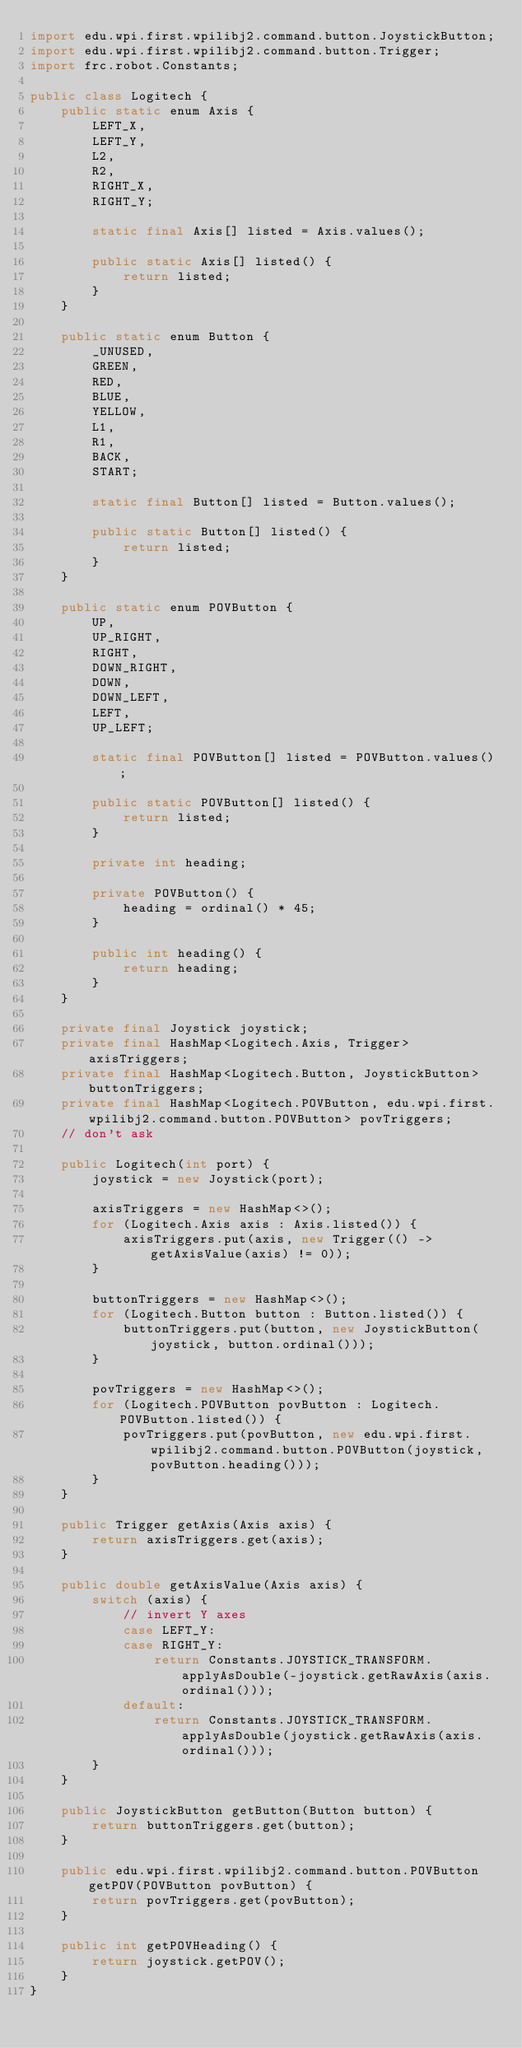Convert code to text. <code><loc_0><loc_0><loc_500><loc_500><_Java_>import edu.wpi.first.wpilibj2.command.button.JoystickButton;
import edu.wpi.first.wpilibj2.command.button.Trigger;
import frc.robot.Constants;

public class Logitech {
    public static enum Axis {
        LEFT_X,
        LEFT_Y,
        L2,
        R2,
        RIGHT_X,
        RIGHT_Y;

        static final Axis[] listed = Axis.values();

        public static Axis[] listed() {
            return listed;
        }
    }

    public static enum Button {
        _UNUSED,
        GREEN,
        RED,
        BLUE,
        YELLOW,
        L1,
        R1,
        BACK,
        START;
    
        static final Button[] listed = Button.values();

        public static Button[] listed() {
            return listed;
        }
    }

    public static enum POVButton {
        UP,
        UP_RIGHT,
        RIGHT,
        DOWN_RIGHT,
        DOWN,
        DOWN_LEFT,
        LEFT,
        UP_LEFT;

        static final POVButton[] listed = POVButton.values();

        public static POVButton[] listed() {
            return listed;
        }

        private int heading;

        private POVButton() {
            heading = ordinal() * 45;
        }

        public int heading() {
            return heading;
        }
    }

    private final Joystick joystick;
    private final HashMap<Logitech.Axis, Trigger> axisTriggers;
    private final HashMap<Logitech.Button, JoystickButton> buttonTriggers;
    private final HashMap<Logitech.POVButton, edu.wpi.first.wpilibj2.command.button.POVButton> povTriggers;
    // don't ask

    public Logitech(int port) {
        joystick = new Joystick(port);

        axisTriggers = new HashMap<>();
        for (Logitech.Axis axis : Axis.listed()) {
            axisTriggers.put(axis, new Trigger(() -> getAxisValue(axis) != 0));
        }

        buttonTriggers = new HashMap<>();
        for (Logitech.Button button : Button.listed()) {
            buttonTriggers.put(button, new JoystickButton(joystick, button.ordinal()));
        }

        povTriggers = new HashMap<>();
        for (Logitech.POVButton povButton : Logitech.POVButton.listed()) {
            povTriggers.put(povButton, new edu.wpi.first.wpilibj2.command.button.POVButton(joystick, povButton.heading()));
        }
    }

    public Trigger getAxis(Axis axis) {
        return axisTriggers.get(axis);
    }

    public double getAxisValue(Axis axis) {
        switch (axis) {
            // invert Y axes
            case LEFT_Y:
            case RIGHT_Y:
                return Constants.JOYSTICK_TRANSFORM.applyAsDouble(-joystick.getRawAxis(axis.ordinal()));
            default:
                return Constants.JOYSTICK_TRANSFORM.applyAsDouble(joystick.getRawAxis(axis.ordinal()));
        }
    }

    public JoystickButton getButton(Button button) {
        return buttonTriggers.get(button);
    }

    public edu.wpi.first.wpilibj2.command.button.POVButton getPOV(POVButton povButton) {
        return povTriggers.get(povButton);
    }

    public int getPOVHeading() {
        return joystick.getPOV();
    }
}
</code> 